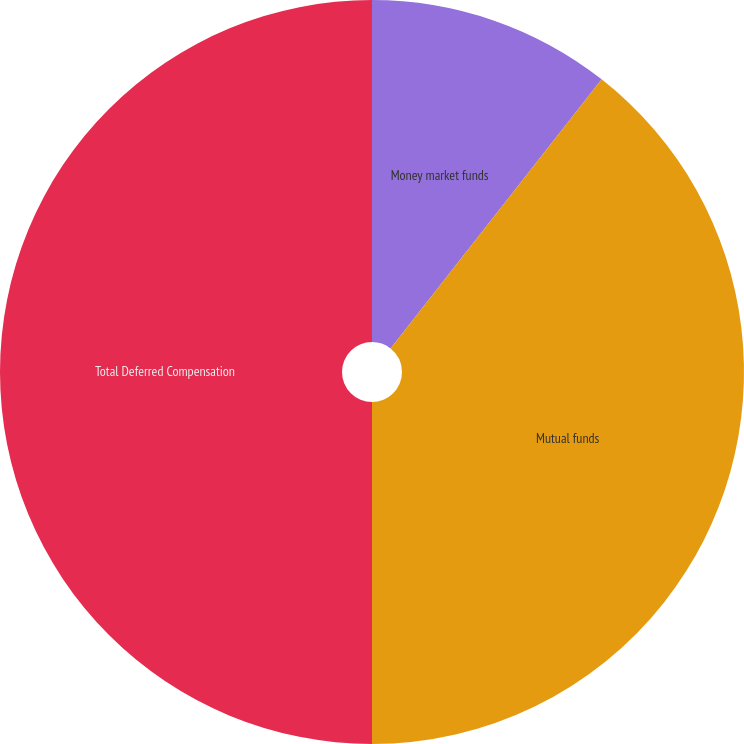Convert chart. <chart><loc_0><loc_0><loc_500><loc_500><pie_chart><fcel>Money market funds<fcel>Mutual funds<fcel>Total Deferred Compensation<nl><fcel>10.59%<fcel>39.41%<fcel>50.0%<nl></chart> 